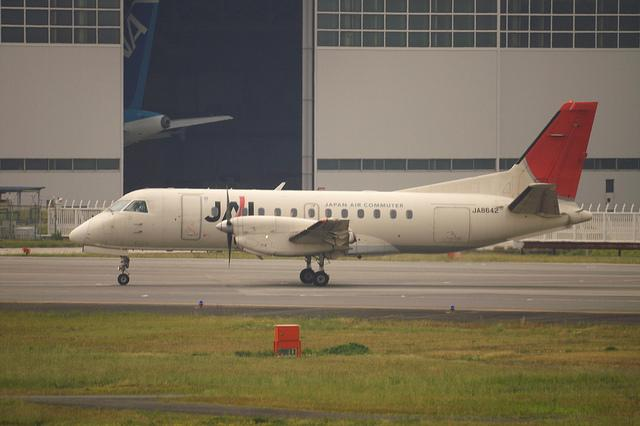What color is the tip of the tailfin on the Japanese propeller plane? red 